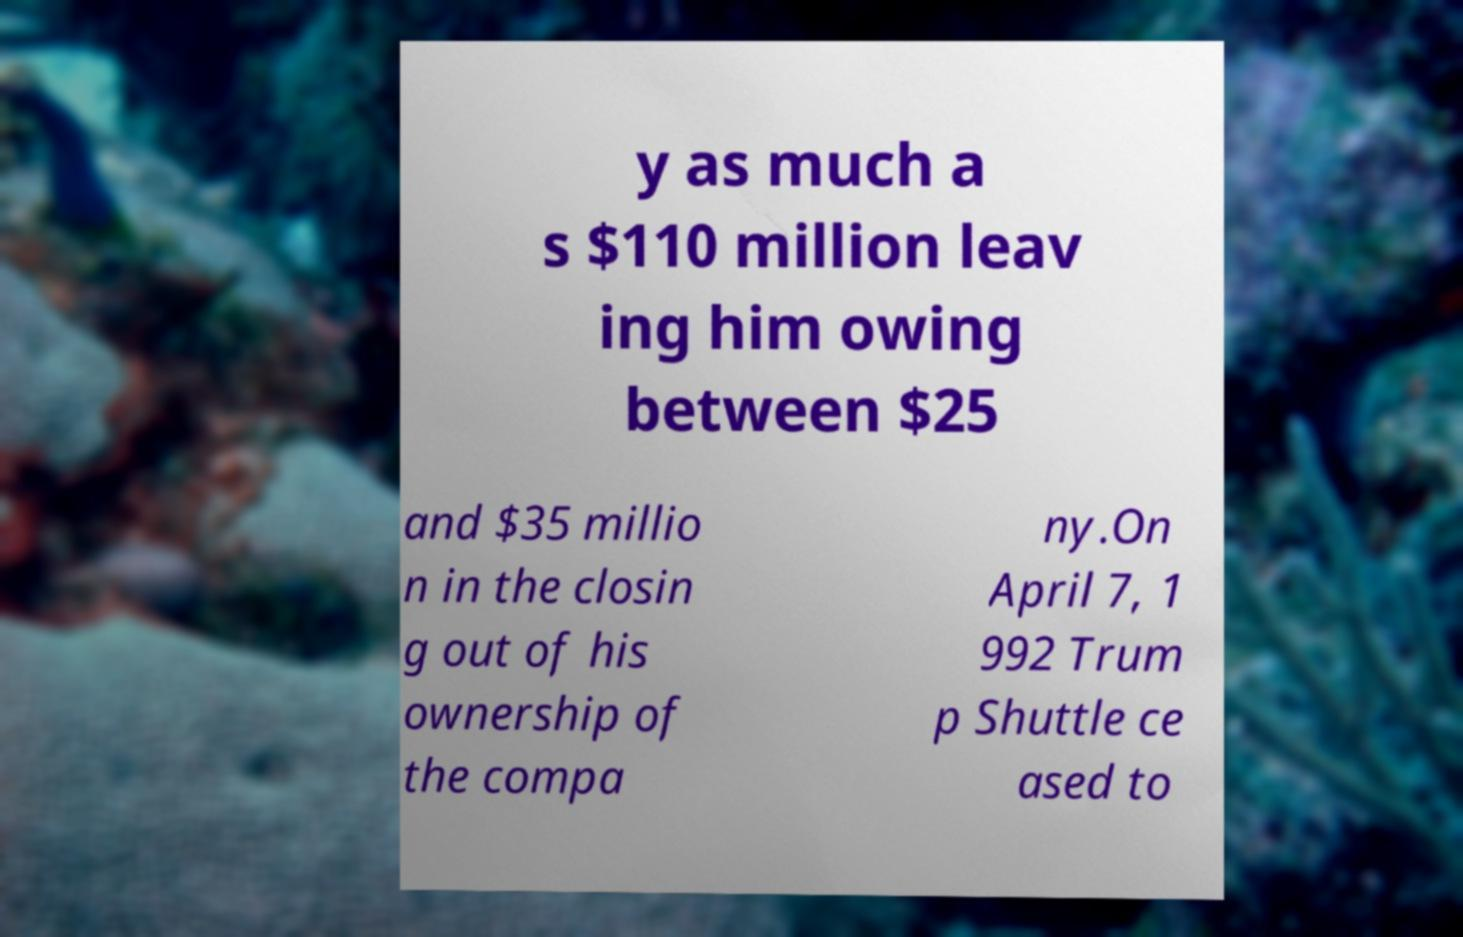Can you read and provide the text displayed in the image?This photo seems to have some interesting text. Can you extract and type it out for me? y as much a s $110 million leav ing him owing between $25 and $35 millio n in the closin g out of his ownership of the compa ny.On April 7, 1 992 Trum p Shuttle ce ased to 